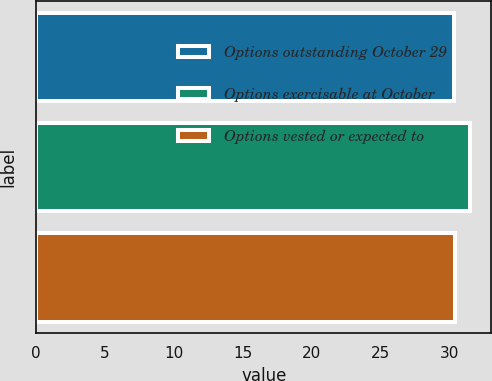Convert chart to OTSL. <chart><loc_0><loc_0><loc_500><loc_500><bar_chart><fcel>Options outstanding October 29<fcel>Options exercisable at October<fcel>Options vested or expected to<nl><fcel>30.27<fcel>31.44<fcel>30.39<nl></chart> 